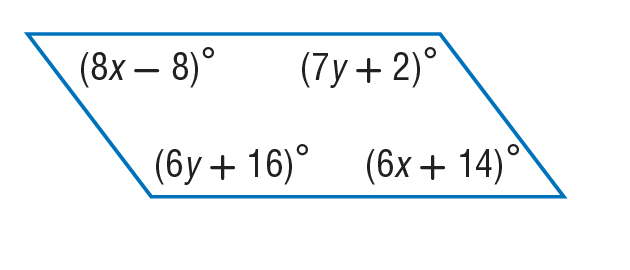Question: Find x so that the quadrilateral is a parallelogram.
Choices:
A. 11
B. 14
C. 77
D. 98
Answer with the letter. Answer: A 